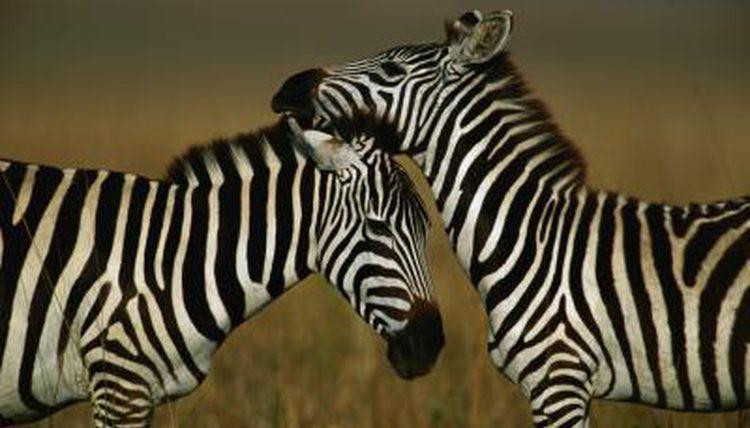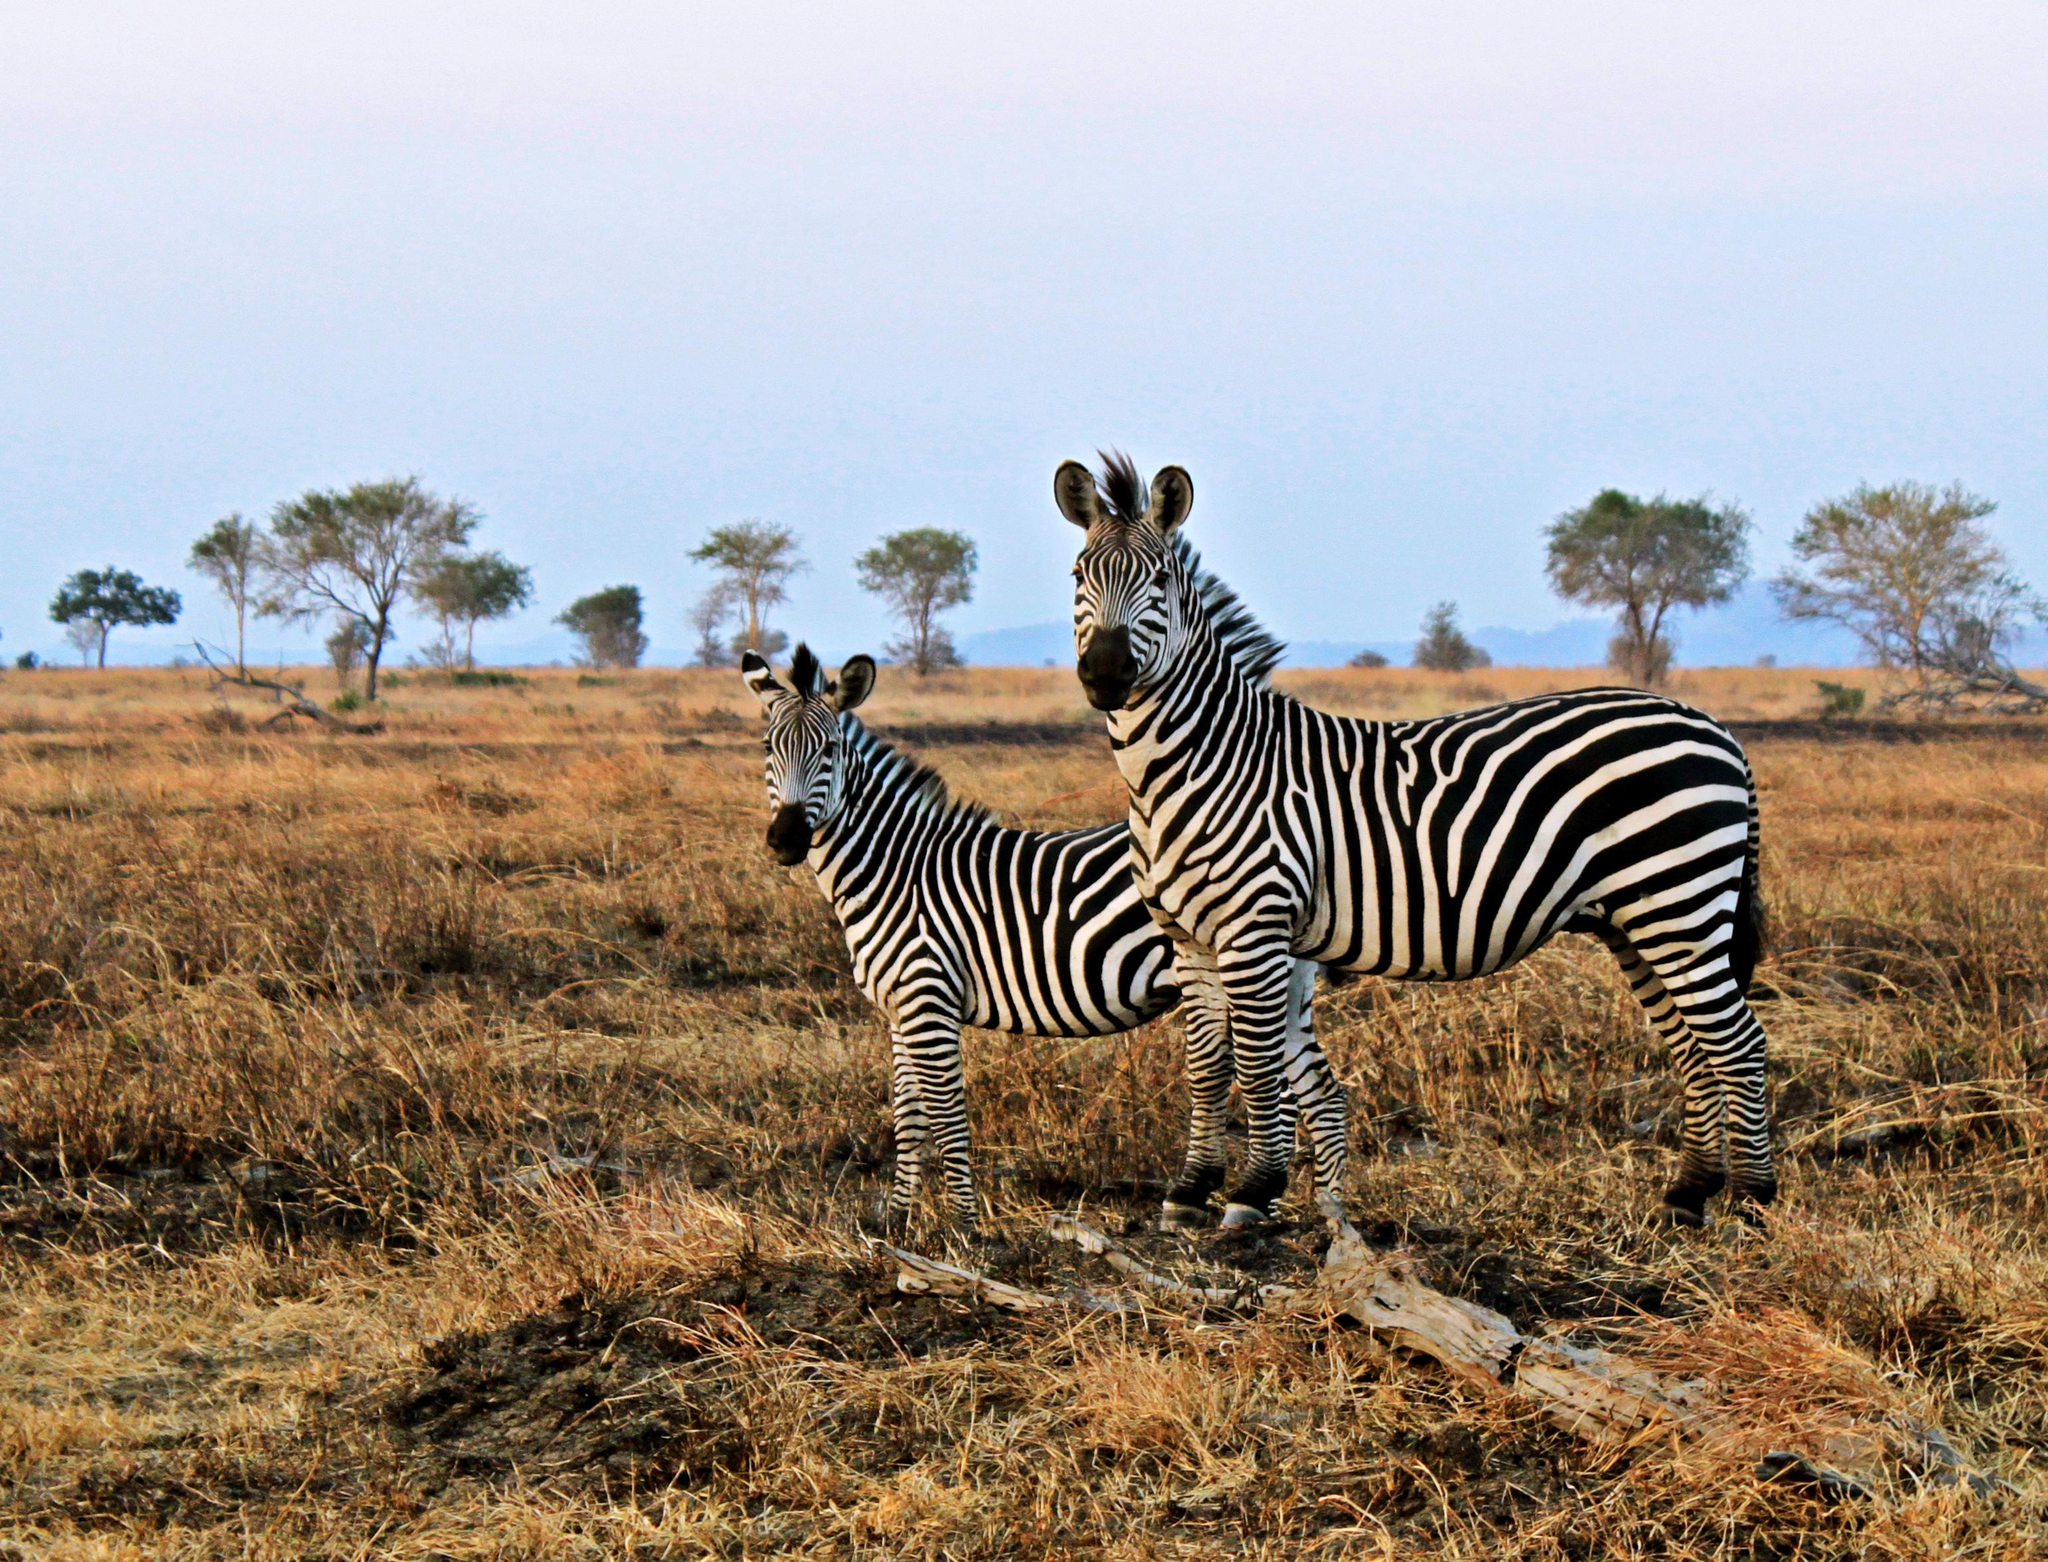The first image is the image on the left, the second image is the image on the right. Evaluate the accuracy of this statement regarding the images: "There are three zebras". Is it true? Answer yes or no. No. 